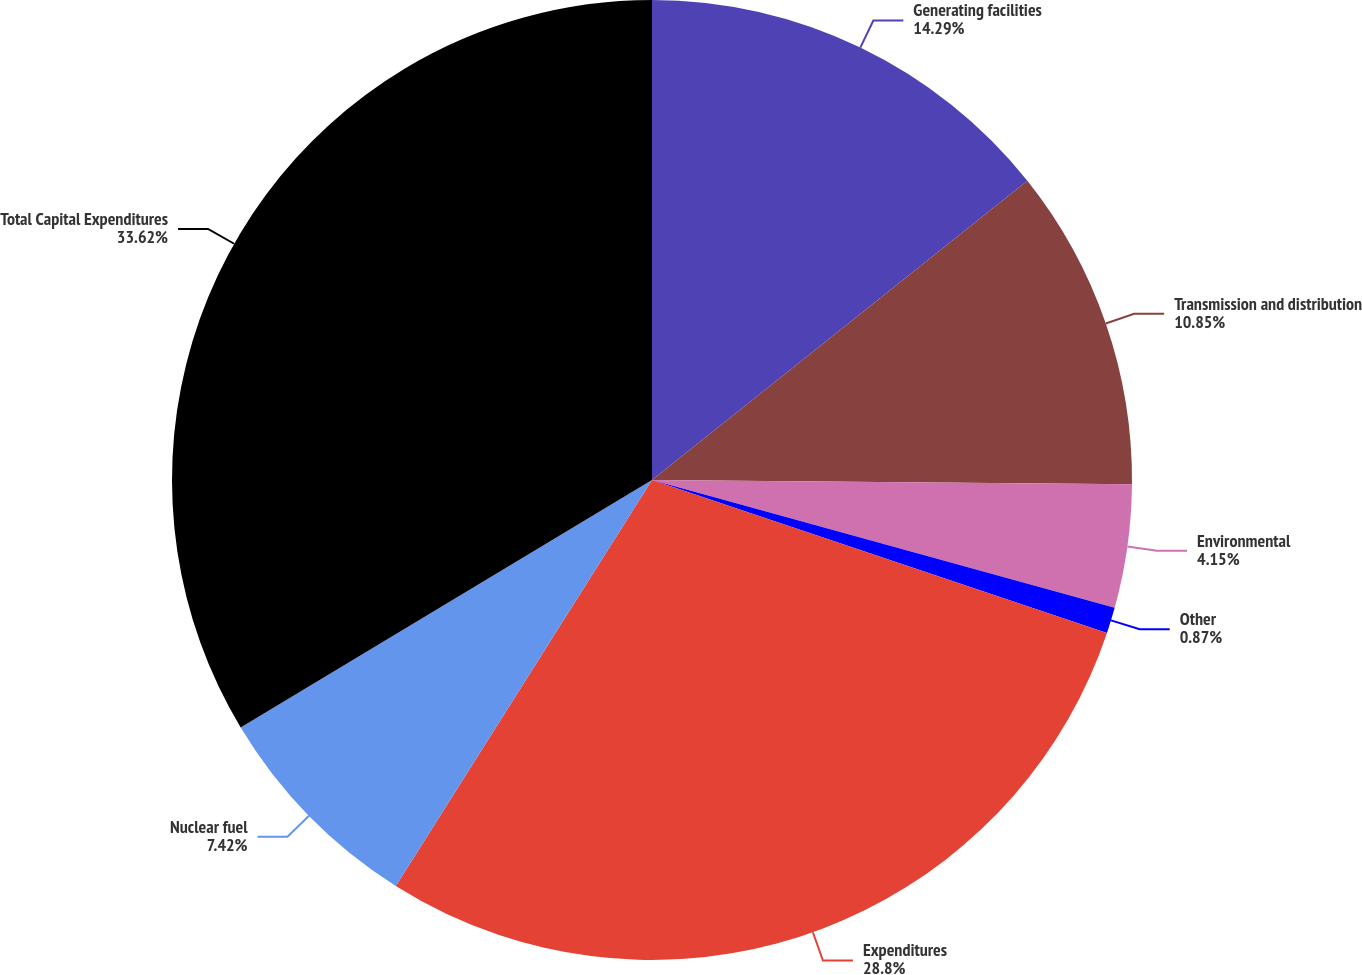Convert chart to OTSL. <chart><loc_0><loc_0><loc_500><loc_500><pie_chart><fcel>Generating facilities<fcel>Transmission and distribution<fcel>Environmental<fcel>Other<fcel>Expenditures<fcel>Nuclear fuel<fcel>Total Capital Expenditures<nl><fcel>14.29%<fcel>10.85%<fcel>4.15%<fcel>0.87%<fcel>28.8%<fcel>7.42%<fcel>33.62%<nl></chart> 